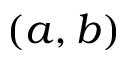Convert formula to latex. <formula><loc_0><loc_0><loc_500><loc_500>( a , b )</formula> 